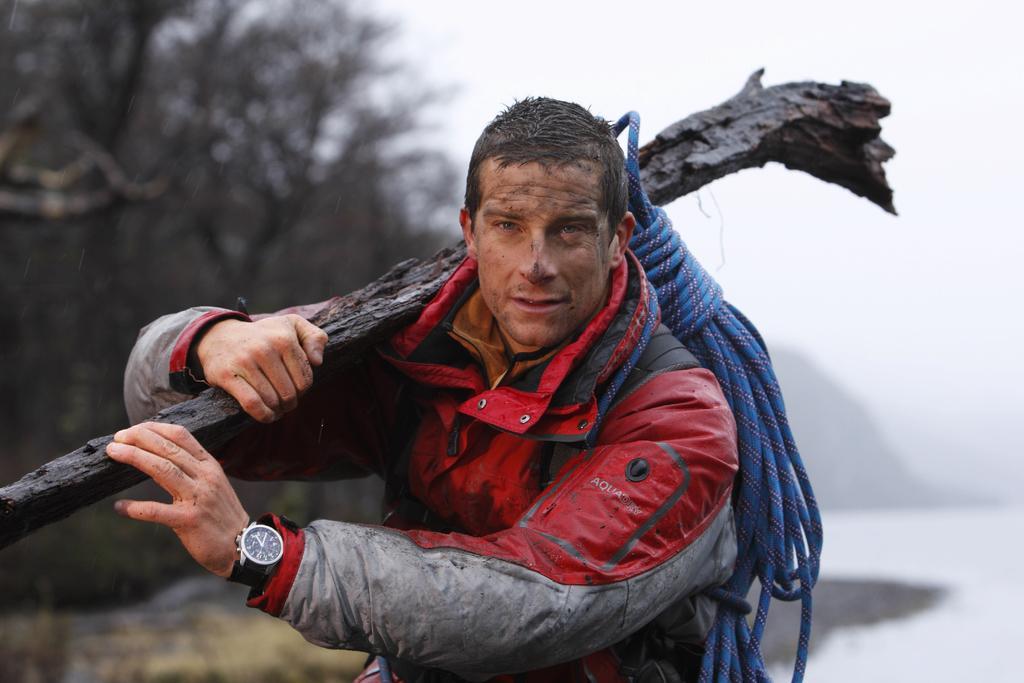Describe this image in one or two sentences. In this image I can see a person and the person is wearing red and gray color jacket and the person is holding some object. Background I can see trees, and the sky is in white color. 